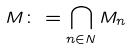Convert formula to latex. <formula><loc_0><loc_0><loc_500><loc_500>M \colon = \bigcap _ { n \in N } M _ { n }</formula> 